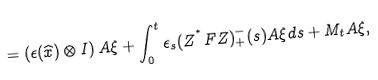<formula> <loc_0><loc_0><loc_500><loc_500>= \left ( \epsilon ( \widehat { x } ) \otimes I \right ) A \xi + \int _ { 0 } ^ { t } \epsilon _ { s } ( Z ^ { ^ { * } } F Z ) _ { + } ^ { - } ( s ) A \xi d s + M _ { t } A \xi ,</formula> 